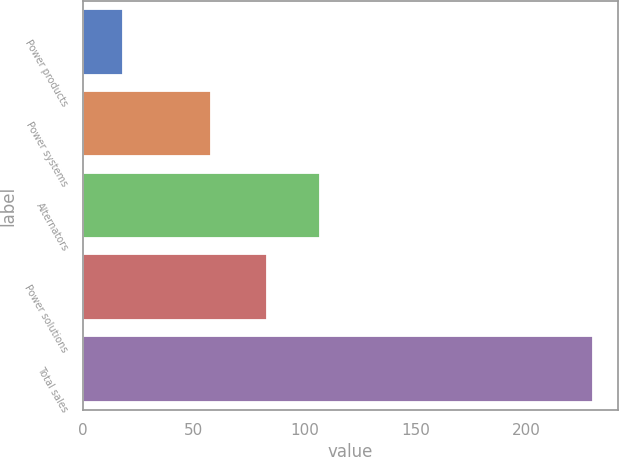Convert chart to OTSL. <chart><loc_0><loc_0><loc_500><loc_500><bar_chart><fcel>Power products<fcel>Power systems<fcel>Alternators<fcel>Power solutions<fcel>Total sales<nl><fcel>18<fcel>58<fcel>107<fcel>83<fcel>230<nl></chart> 